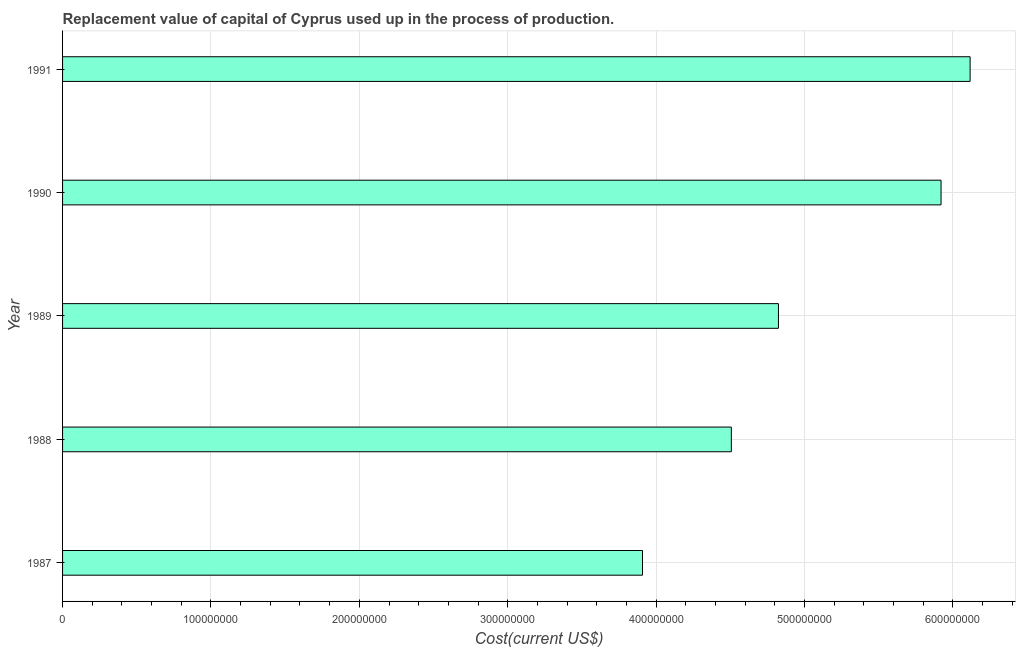Does the graph contain grids?
Your answer should be compact. Yes. What is the title of the graph?
Provide a short and direct response. Replacement value of capital of Cyprus used up in the process of production. What is the label or title of the X-axis?
Your response must be concise. Cost(current US$). What is the label or title of the Y-axis?
Your response must be concise. Year. What is the consumption of fixed capital in 1989?
Provide a succinct answer. 4.82e+08. Across all years, what is the maximum consumption of fixed capital?
Your answer should be compact. 6.12e+08. Across all years, what is the minimum consumption of fixed capital?
Offer a very short reply. 3.91e+08. What is the sum of the consumption of fixed capital?
Offer a terse response. 2.53e+09. What is the difference between the consumption of fixed capital in 1987 and 1990?
Ensure brevity in your answer.  -2.01e+08. What is the average consumption of fixed capital per year?
Your response must be concise. 5.06e+08. What is the median consumption of fixed capital?
Ensure brevity in your answer.  4.82e+08. In how many years, is the consumption of fixed capital greater than 400000000 US$?
Your answer should be very brief. 4. What is the ratio of the consumption of fixed capital in 1987 to that in 1990?
Offer a very short reply. 0.66. Is the consumption of fixed capital in 1988 less than that in 1990?
Your response must be concise. Yes. What is the difference between the highest and the second highest consumption of fixed capital?
Your response must be concise. 1.96e+07. Is the sum of the consumption of fixed capital in 1987 and 1988 greater than the maximum consumption of fixed capital across all years?
Ensure brevity in your answer.  Yes. What is the difference between the highest and the lowest consumption of fixed capital?
Your response must be concise. 2.21e+08. In how many years, is the consumption of fixed capital greater than the average consumption of fixed capital taken over all years?
Your answer should be compact. 2. Are all the bars in the graph horizontal?
Your response must be concise. Yes. What is the difference between two consecutive major ticks on the X-axis?
Provide a succinct answer. 1.00e+08. What is the Cost(current US$) of 1987?
Make the answer very short. 3.91e+08. What is the Cost(current US$) of 1988?
Your response must be concise. 4.51e+08. What is the Cost(current US$) in 1989?
Keep it short and to the point. 4.82e+08. What is the Cost(current US$) in 1990?
Your response must be concise. 5.92e+08. What is the Cost(current US$) in 1991?
Offer a terse response. 6.12e+08. What is the difference between the Cost(current US$) in 1987 and 1988?
Make the answer very short. -5.99e+07. What is the difference between the Cost(current US$) in 1987 and 1989?
Provide a short and direct response. -9.16e+07. What is the difference between the Cost(current US$) in 1987 and 1990?
Keep it short and to the point. -2.01e+08. What is the difference between the Cost(current US$) in 1987 and 1991?
Ensure brevity in your answer.  -2.21e+08. What is the difference between the Cost(current US$) in 1988 and 1989?
Your answer should be very brief. -3.17e+07. What is the difference between the Cost(current US$) in 1988 and 1990?
Your answer should be very brief. -1.41e+08. What is the difference between the Cost(current US$) in 1988 and 1991?
Your answer should be very brief. -1.61e+08. What is the difference between the Cost(current US$) in 1989 and 1990?
Keep it short and to the point. -1.10e+08. What is the difference between the Cost(current US$) in 1989 and 1991?
Offer a terse response. -1.29e+08. What is the difference between the Cost(current US$) in 1990 and 1991?
Offer a very short reply. -1.96e+07. What is the ratio of the Cost(current US$) in 1987 to that in 1988?
Provide a short and direct response. 0.87. What is the ratio of the Cost(current US$) in 1987 to that in 1989?
Provide a succinct answer. 0.81. What is the ratio of the Cost(current US$) in 1987 to that in 1990?
Ensure brevity in your answer.  0.66. What is the ratio of the Cost(current US$) in 1987 to that in 1991?
Your answer should be very brief. 0.64. What is the ratio of the Cost(current US$) in 1988 to that in 1989?
Offer a very short reply. 0.93. What is the ratio of the Cost(current US$) in 1988 to that in 1990?
Provide a short and direct response. 0.76. What is the ratio of the Cost(current US$) in 1988 to that in 1991?
Your response must be concise. 0.74. What is the ratio of the Cost(current US$) in 1989 to that in 1990?
Your answer should be compact. 0.81. What is the ratio of the Cost(current US$) in 1989 to that in 1991?
Your answer should be compact. 0.79. What is the ratio of the Cost(current US$) in 1990 to that in 1991?
Make the answer very short. 0.97. 